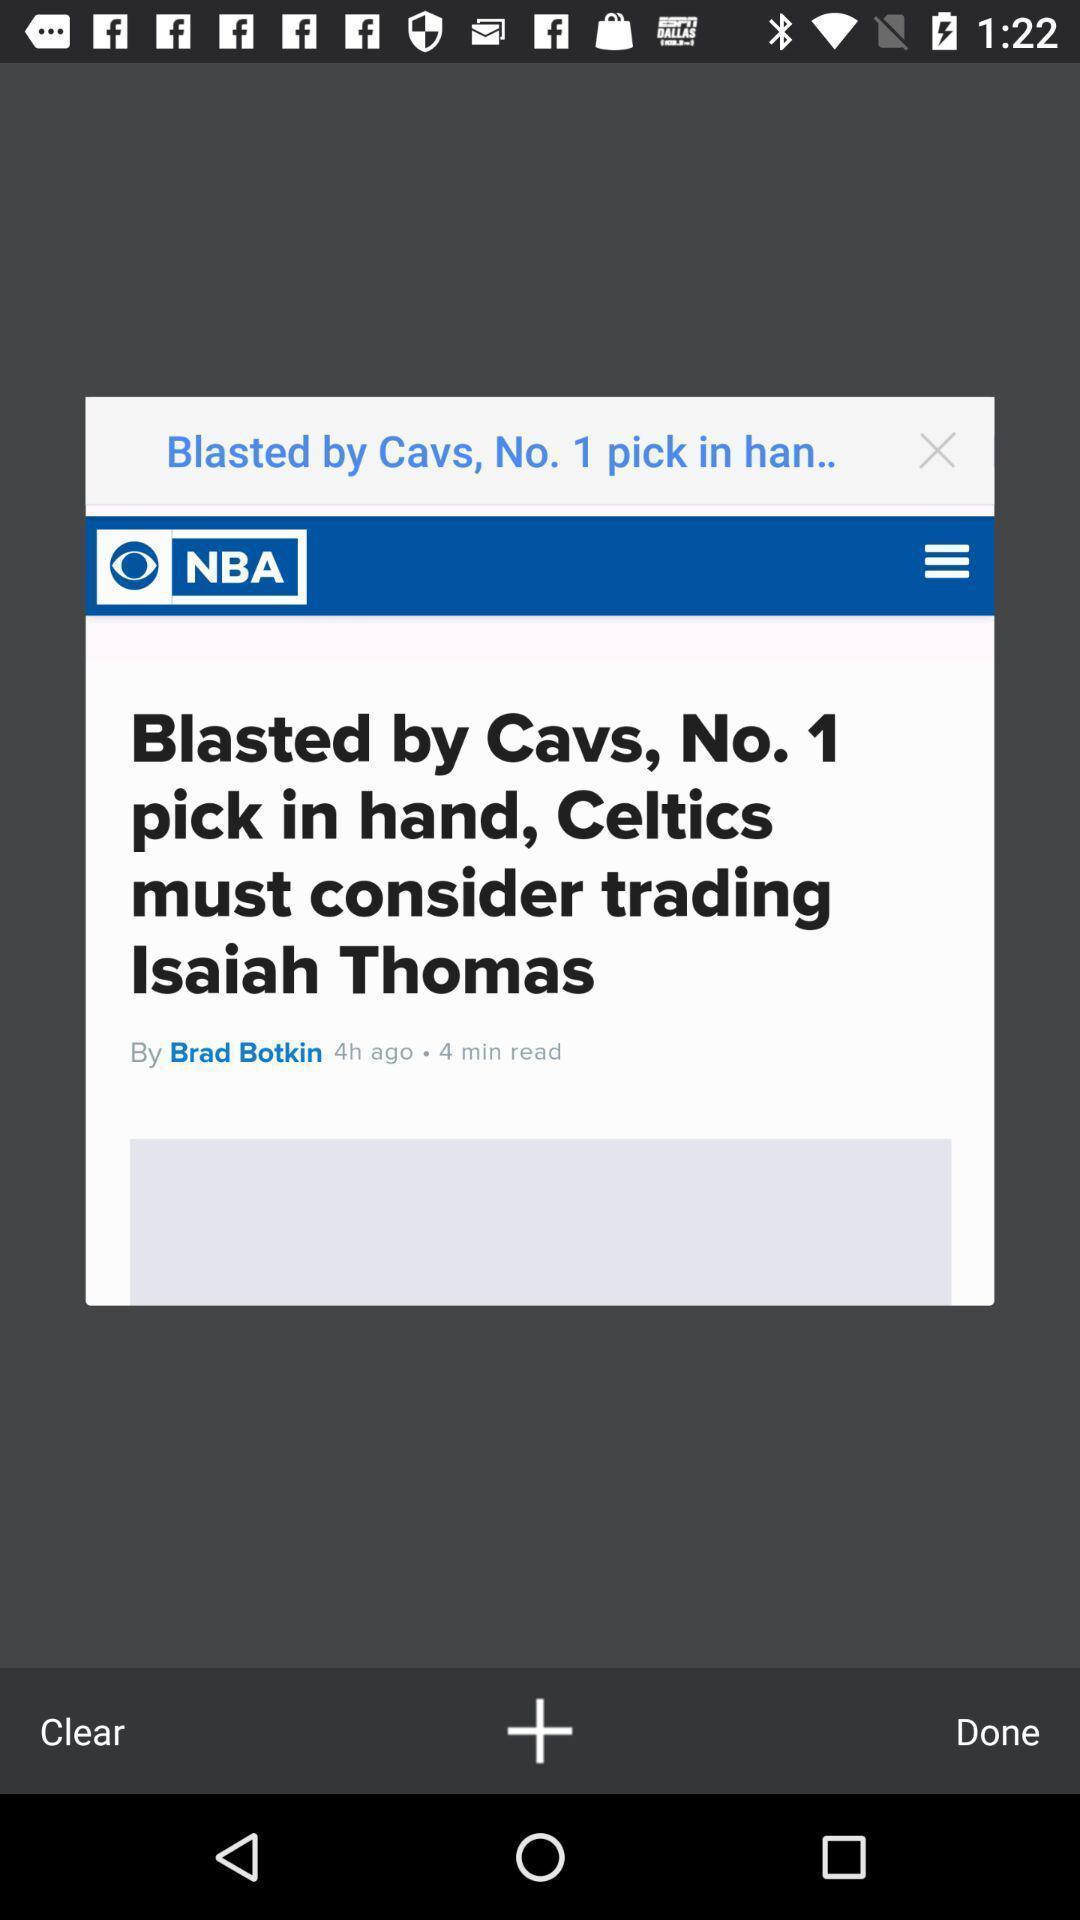Give me a summary of this screen capture. Screen displaying the popup of a news. 